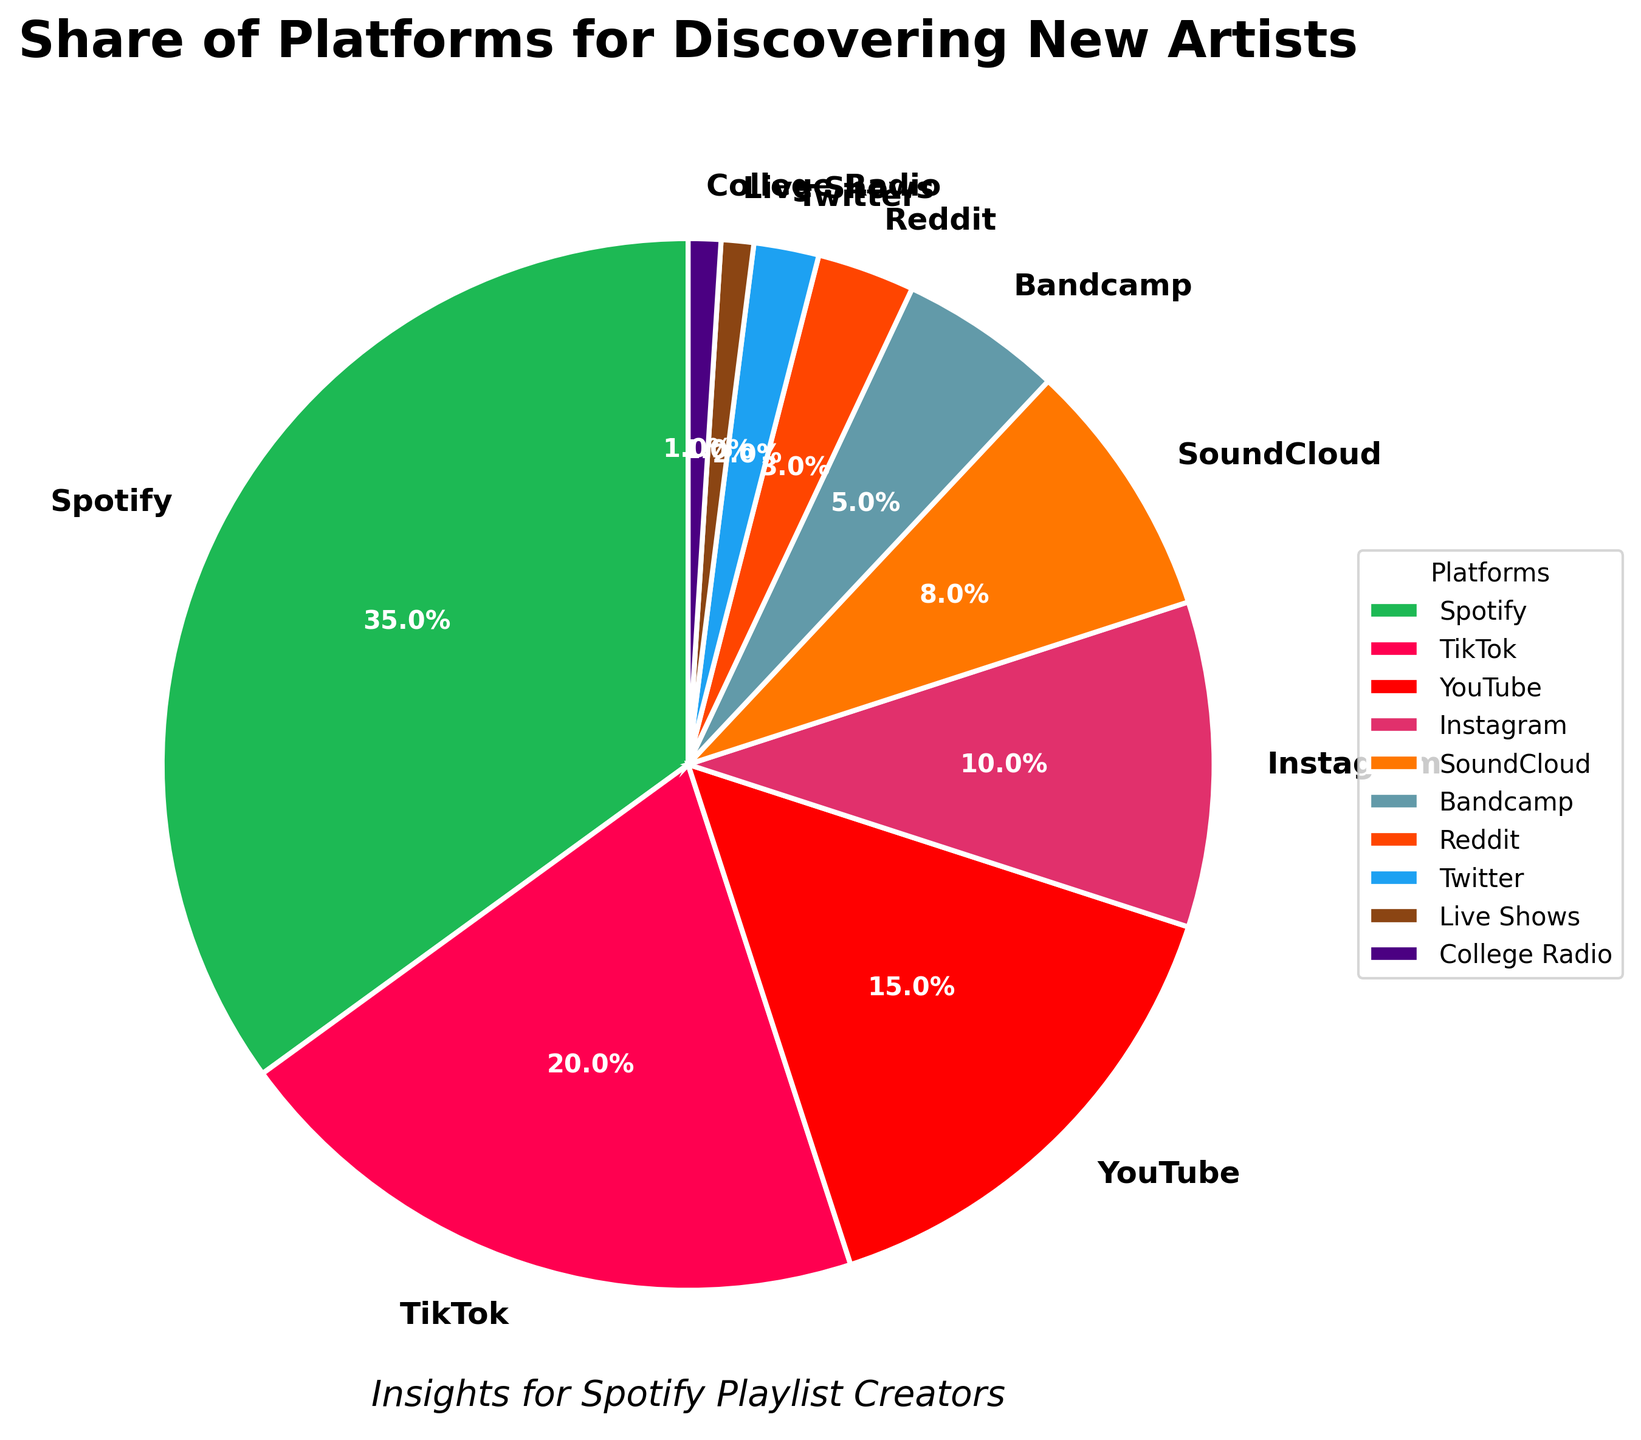What's the most used platform for discovering new artists? Start by looking at the platform with the highest percentage. According to the pie chart, Spotify has the largest segment.
Answer: Spotify What percentage of people use TikTok and Instagram combined for discovering new artists? Add the percentages of TikTok and Instagram. According to the figure, TikTok is 20% and Instagram is 10%. So, 20% + 10% = 30%.
Answer: 30% Which platform has a higher share for discovering new artists, YouTube or SoundCloud? Compare the segments for YouTube and SoundCloud. YouTube has 15%, while SoundCloud has 8%. 15% is greater than 8%.
Answer: YouTube How much larger is the percentage of people discovering new artists on Spotify compared to Bandcamp? Subtract Bandcamp's percentage from Spotify's percentage. According to the figure, Spotify is at 35% and Bandcamp is at 5%. So, 35% - 5% = 30%.
Answer: 30% What portion of the pie chart is represented by platforms with less than 3% share? Sum the percentages of platforms with less than 3% (Reddit, Twitter, Live Shows, College Radio). Reddit is 3%, Twitter is 2%, Live Shows is 1%, and College Radio is 1%. So, 3% + 2% + 1% + 1% = 7%.
Answer: 7% Between TikTok and YouTube, which one is more popular for discovering new artists, and by how much? Compare their percentages. TikTok is at 20% and YouTube is at 15%. The difference is 20% - 15% = 5%.
Answer: TikTok by 5% Are there more people using Instagram or SoundCloud for discovering new artists? Compare the percentages of Instagram and SoundCloud. Instagram is at 10% and SoundCloud is at 8%. 10% is greater than 8%.
Answer: Instagram What is the total percentage covered by platforms other than Spotify? Subtract Spotify's percentage from 100%. Spotify is 35%, so 100% - 35% = 65%.
Answer: 65% What do the green and pink segments of the pie chart represent? The green segment represents Spotify, and the pink segment represents TikTok.
Answer: Spotify (green) and TikTok (pink) 